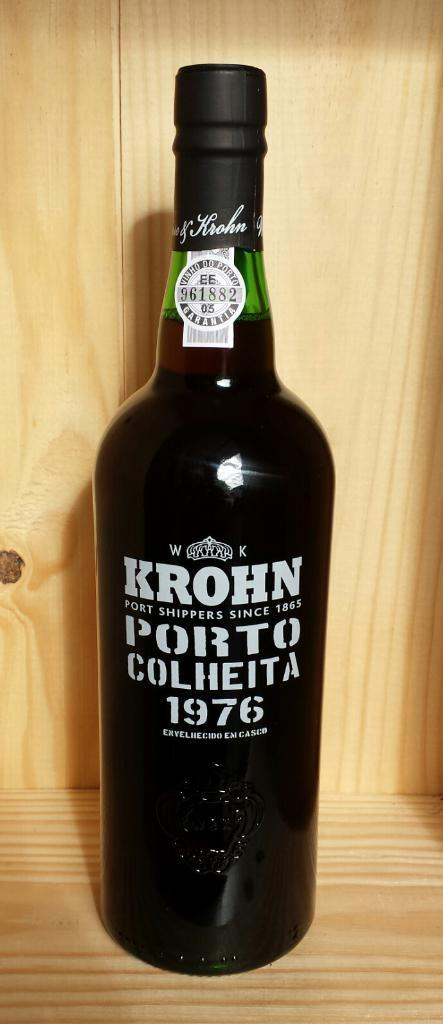<image>
Summarize the visual content of the image. a bottle of krohn porto colheita from 1976 